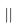<formula> <loc_0><loc_0><loc_500><loc_500>| |</formula> 